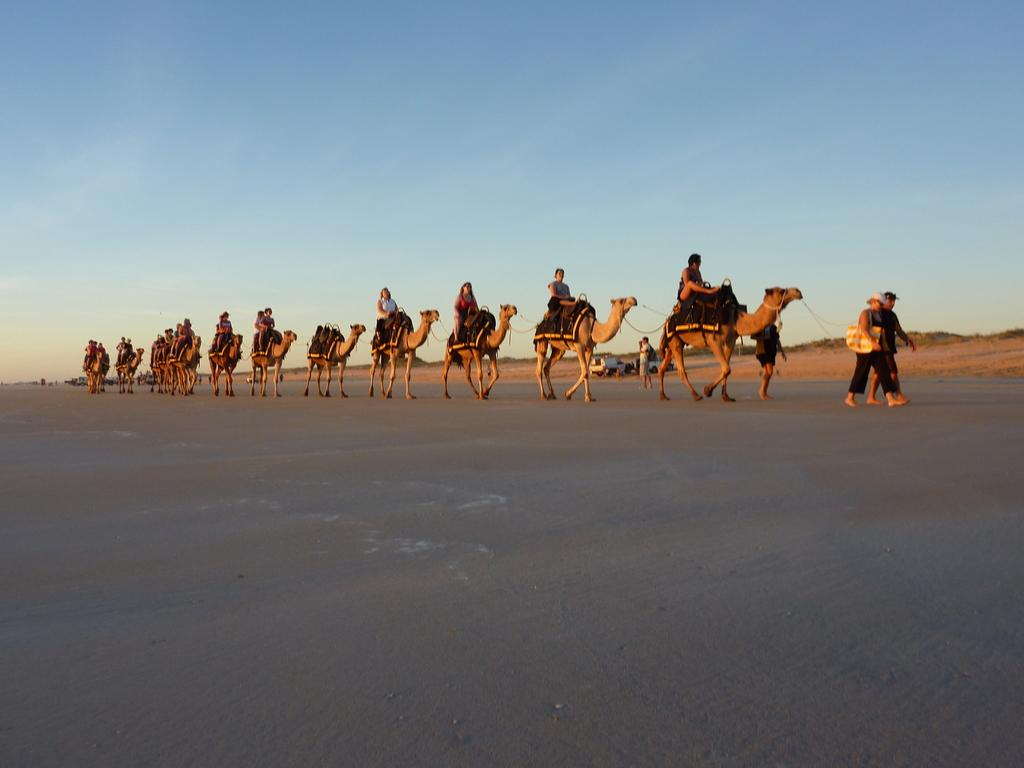What are the people in the image doing? The people in the image are riding camels. How many people are riding camels in the image? There are four persons standing in the image, and they are all riding camels. What else can be seen in the image besides the people and camels? There are vehicles in the image. What is visible in the background of the image? The sky is visible in the background of the image. What type of seat can be seen in the circle in the image? There is no seat or circle present in the image; it features a group of people riding camels and vehicles. 